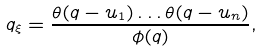Convert formula to latex. <formula><loc_0><loc_0><loc_500><loc_500>q _ { \xi } = \frac { \theta ( q - u _ { 1 } ) \dots \theta ( q - u _ { n } ) } { \phi ( q ) } ,</formula> 